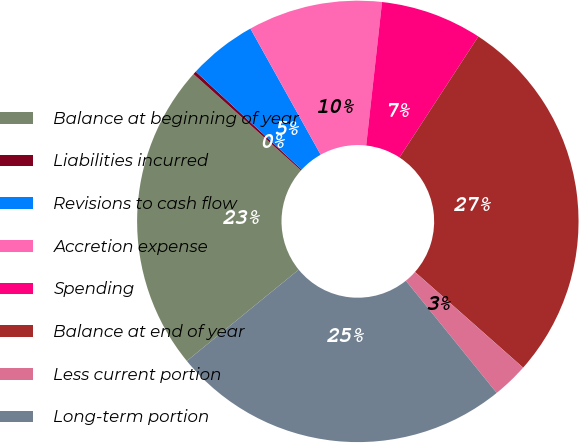Convert chart. <chart><loc_0><loc_0><loc_500><loc_500><pie_chart><fcel>Balance at beginning of year<fcel>Liabilities incurred<fcel>Revisions to cash flow<fcel>Accretion expense<fcel>Spending<fcel>Balance at end of year<fcel>Less current portion<fcel>Long-term portion<nl><fcel>22.53%<fcel>0.24%<fcel>5.04%<fcel>9.84%<fcel>7.44%<fcel>27.34%<fcel>2.64%<fcel>24.94%<nl></chart> 